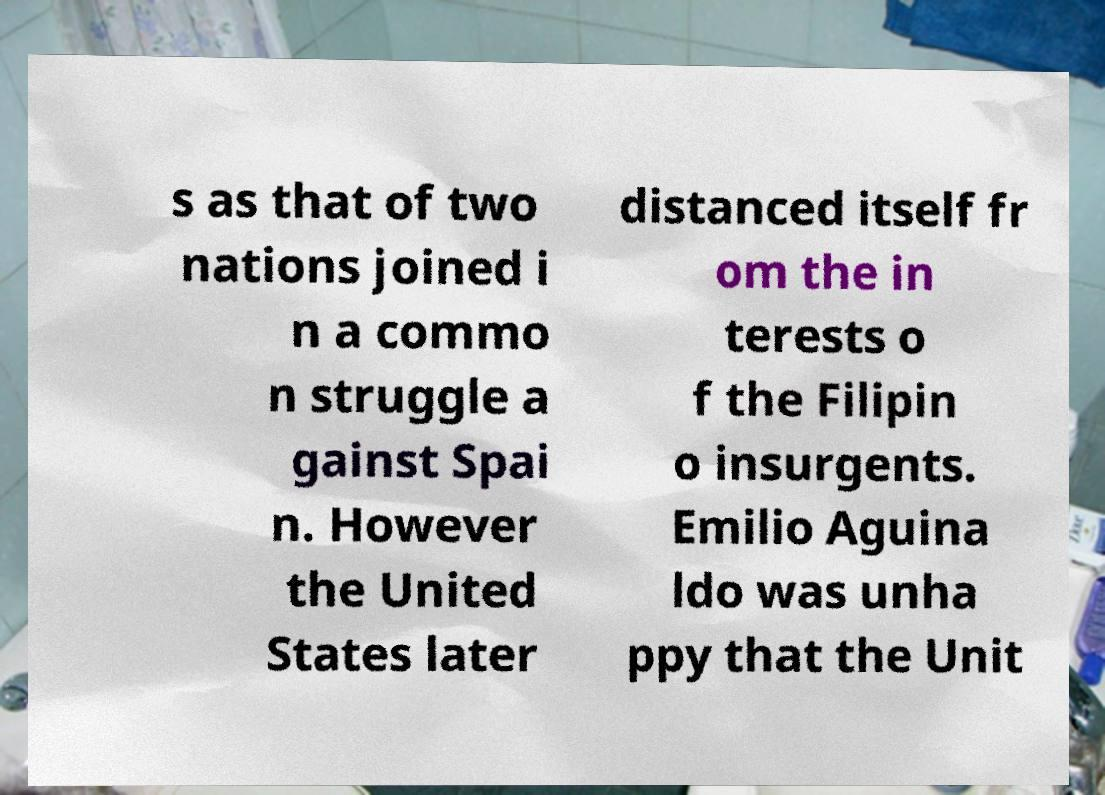Can you accurately transcribe the text from the provided image for me? s as that of two nations joined i n a commo n struggle a gainst Spai n. However the United States later distanced itself fr om the in terests o f the Filipin o insurgents. Emilio Aguina ldo was unha ppy that the Unit 